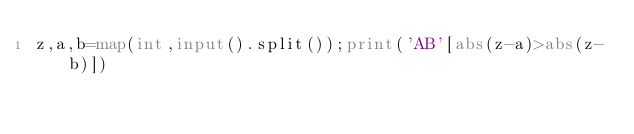<code> <loc_0><loc_0><loc_500><loc_500><_Python_>z,a,b=map(int,input().split());print('AB'[abs(z-a)>abs(z-b)])</code> 